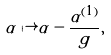Convert formula to latex. <formula><loc_0><loc_0><loc_500><loc_500>\alpha \mapsto \alpha - \frac { \alpha ^ { ( 1 ) } } { g } ,</formula> 